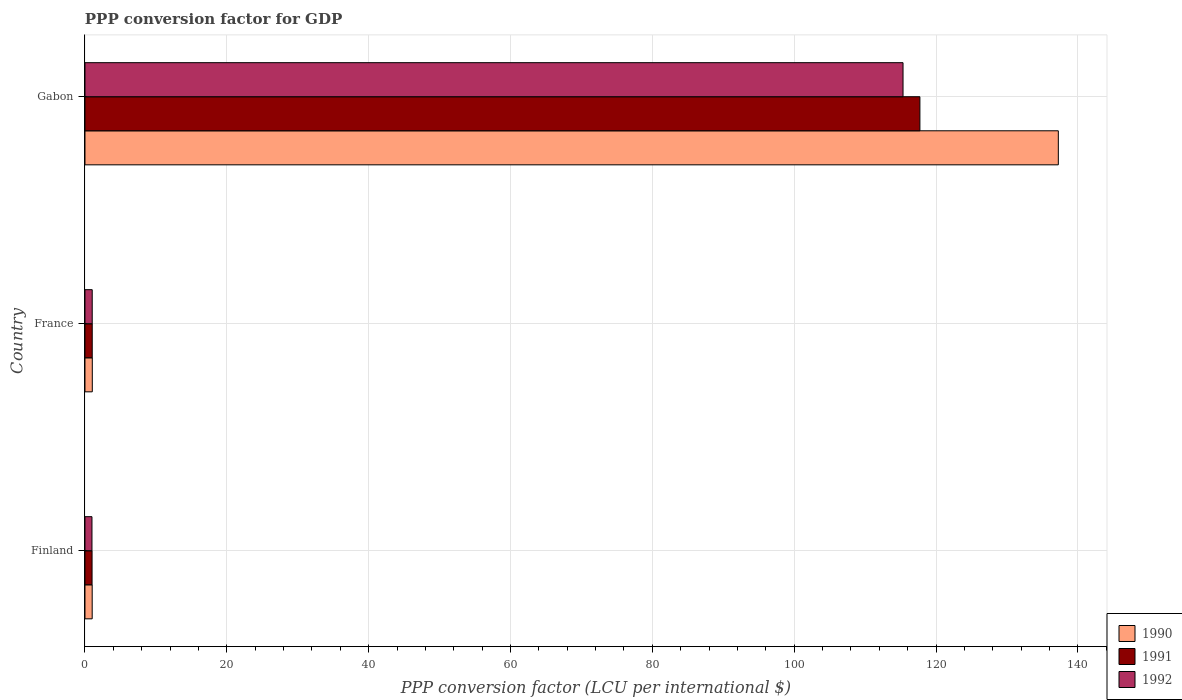What is the label of the 1st group of bars from the top?
Provide a short and direct response. Gabon. What is the PPP conversion factor for GDP in 1990 in Finland?
Provide a succinct answer. 1.02. Across all countries, what is the maximum PPP conversion factor for GDP in 1990?
Provide a short and direct response. 137.25. Across all countries, what is the minimum PPP conversion factor for GDP in 1991?
Your response must be concise. 1. In which country was the PPP conversion factor for GDP in 1992 maximum?
Give a very brief answer. Gabon. What is the total PPP conversion factor for GDP in 1991 in the graph?
Provide a short and direct response. 119.75. What is the difference between the PPP conversion factor for GDP in 1991 in France and that in Gabon?
Your response must be concise. -116.7. What is the difference between the PPP conversion factor for GDP in 1991 in Gabon and the PPP conversion factor for GDP in 1992 in Finland?
Keep it short and to the point. 116.74. What is the average PPP conversion factor for GDP in 1991 per country?
Ensure brevity in your answer.  39.92. What is the difference between the PPP conversion factor for GDP in 1992 and PPP conversion factor for GDP in 1990 in France?
Ensure brevity in your answer.  -0.01. What is the ratio of the PPP conversion factor for GDP in 1992 in Finland to that in France?
Offer a terse response. 0.97. What is the difference between the highest and the second highest PPP conversion factor for GDP in 1991?
Offer a very short reply. 116.7. What is the difference between the highest and the lowest PPP conversion factor for GDP in 1992?
Provide a short and direct response. 114.36. What does the 3rd bar from the bottom in Gabon represents?
Your answer should be compact. 1992. How many bars are there?
Your answer should be compact. 9. Are all the bars in the graph horizontal?
Offer a very short reply. Yes. How many countries are there in the graph?
Provide a succinct answer. 3. What is the difference between two consecutive major ticks on the X-axis?
Your answer should be compact. 20. What is the title of the graph?
Make the answer very short. PPP conversion factor for GDP. Does "1978" appear as one of the legend labels in the graph?
Your answer should be compact. No. What is the label or title of the X-axis?
Provide a succinct answer. PPP conversion factor (LCU per international $). What is the label or title of the Y-axis?
Offer a terse response. Country. What is the PPP conversion factor (LCU per international $) in 1990 in Finland?
Offer a terse response. 1.02. What is the PPP conversion factor (LCU per international $) in 1991 in Finland?
Your response must be concise. 1. What is the PPP conversion factor (LCU per international $) in 1992 in Finland?
Offer a very short reply. 0.99. What is the PPP conversion factor (LCU per international $) of 1990 in France?
Your answer should be compact. 1.03. What is the PPP conversion factor (LCU per international $) of 1991 in France?
Keep it short and to the point. 1.02. What is the PPP conversion factor (LCU per international $) in 1992 in France?
Offer a very short reply. 1.02. What is the PPP conversion factor (LCU per international $) of 1990 in Gabon?
Give a very brief answer. 137.25. What is the PPP conversion factor (LCU per international $) of 1991 in Gabon?
Make the answer very short. 117.73. What is the PPP conversion factor (LCU per international $) in 1992 in Gabon?
Your answer should be very brief. 115.35. Across all countries, what is the maximum PPP conversion factor (LCU per international $) in 1990?
Offer a terse response. 137.25. Across all countries, what is the maximum PPP conversion factor (LCU per international $) of 1991?
Offer a terse response. 117.73. Across all countries, what is the maximum PPP conversion factor (LCU per international $) of 1992?
Ensure brevity in your answer.  115.35. Across all countries, what is the minimum PPP conversion factor (LCU per international $) in 1990?
Your answer should be very brief. 1.02. Across all countries, what is the minimum PPP conversion factor (LCU per international $) of 1991?
Provide a short and direct response. 1. Across all countries, what is the minimum PPP conversion factor (LCU per international $) in 1992?
Your answer should be very brief. 0.99. What is the total PPP conversion factor (LCU per international $) of 1990 in the graph?
Provide a short and direct response. 139.3. What is the total PPP conversion factor (LCU per international $) in 1991 in the graph?
Your answer should be compact. 119.75. What is the total PPP conversion factor (LCU per international $) in 1992 in the graph?
Your answer should be compact. 117.36. What is the difference between the PPP conversion factor (LCU per international $) of 1990 in Finland and that in France?
Provide a succinct answer. -0.01. What is the difference between the PPP conversion factor (LCU per international $) of 1991 in Finland and that in France?
Provide a short and direct response. -0.02. What is the difference between the PPP conversion factor (LCU per international $) of 1992 in Finland and that in France?
Offer a very short reply. -0.03. What is the difference between the PPP conversion factor (LCU per international $) in 1990 in Finland and that in Gabon?
Offer a very short reply. -136.23. What is the difference between the PPP conversion factor (LCU per international $) in 1991 in Finland and that in Gabon?
Keep it short and to the point. -116.73. What is the difference between the PPP conversion factor (LCU per international $) in 1992 in Finland and that in Gabon?
Provide a succinct answer. -114.36. What is the difference between the PPP conversion factor (LCU per international $) of 1990 in France and that in Gabon?
Provide a short and direct response. -136.21. What is the difference between the PPP conversion factor (LCU per international $) of 1991 in France and that in Gabon?
Provide a succinct answer. -116.7. What is the difference between the PPP conversion factor (LCU per international $) of 1992 in France and that in Gabon?
Your answer should be very brief. -114.33. What is the difference between the PPP conversion factor (LCU per international $) of 1990 in Finland and the PPP conversion factor (LCU per international $) of 1991 in France?
Make the answer very short. -0.01. What is the difference between the PPP conversion factor (LCU per international $) of 1990 in Finland and the PPP conversion factor (LCU per international $) of 1992 in France?
Ensure brevity in your answer.  -0. What is the difference between the PPP conversion factor (LCU per international $) in 1991 in Finland and the PPP conversion factor (LCU per international $) in 1992 in France?
Offer a very short reply. -0.02. What is the difference between the PPP conversion factor (LCU per international $) in 1990 in Finland and the PPP conversion factor (LCU per international $) in 1991 in Gabon?
Make the answer very short. -116.71. What is the difference between the PPP conversion factor (LCU per international $) in 1990 in Finland and the PPP conversion factor (LCU per international $) in 1992 in Gabon?
Your answer should be compact. -114.33. What is the difference between the PPP conversion factor (LCU per international $) in 1991 in Finland and the PPP conversion factor (LCU per international $) in 1992 in Gabon?
Make the answer very short. -114.35. What is the difference between the PPP conversion factor (LCU per international $) of 1990 in France and the PPP conversion factor (LCU per international $) of 1991 in Gabon?
Offer a very short reply. -116.7. What is the difference between the PPP conversion factor (LCU per international $) in 1990 in France and the PPP conversion factor (LCU per international $) in 1992 in Gabon?
Give a very brief answer. -114.32. What is the difference between the PPP conversion factor (LCU per international $) in 1991 in France and the PPP conversion factor (LCU per international $) in 1992 in Gabon?
Give a very brief answer. -114.33. What is the average PPP conversion factor (LCU per international $) in 1990 per country?
Offer a terse response. 46.43. What is the average PPP conversion factor (LCU per international $) in 1991 per country?
Offer a terse response. 39.92. What is the average PPP conversion factor (LCU per international $) in 1992 per country?
Your answer should be compact. 39.12. What is the difference between the PPP conversion factor (LCU per international $) in 1990 and PPP conversion factor (LCU per international $) in 1991 in Finland?
Make the answer very short. 0.02. What is the difference between the PPP conversion factor (LCU per international $) of 1990 and PPP conversion factor (LCU per international $) of 1992 in Finland?
Your answer should be very brief. 0.03. What is the difference between the PPP conversion factor (LCU per international $) of 1991 and PPP conversion factor (LCU per international $) of 1992 in Finland?
Your answer should be very brief. 0.01. What is the difference between the PPP conversion factor (LCU per international $) in 1990 and PPP conversion factor (LCU per international $) in 1991 in France?
Your answer should be very brief. 0.01. What is the difference between the PPP conversion factor (LCU per international $) in 1990 and PPP conversion factor (LCU per international $) in 1992 in France?
Offer a very short reply. 0.01. What is the difference between the PPP conversion factor (LCU per international $) in 1991 and PPP conversion factor (LCU per international $) in 1992 in France?
Your answer should be compact. 0. What is the difference between the PPP conversion factor (LCU per international $) in 1990 and PPP conversion factor (LCU per international $) in 1991 in Gabon?
Keep it short and to the point. 19.52. What is the difference between the PPP conversion factor (LCU per international $) in 1990 and PPP conversion factor (LCU per international $) in 1992 in Gabon?
Provide a short and direct response. 21.9. What is the difference between the PPP conversion factor (LCU per international $) in 1991 and PPP conversion factor (LCU per international $) in 1992 in Gabon?
Your answer should be compact. 2.38. What is the ratio of the PPP conversion factor (LCU per international $) of 1990 in Finland to that in France?
Provide a short and direct response. 0.99. What is the ratio of the PPP conversion factor (LCU per international $) in 1991 in Finland to that in France?
Provide a short and direct response. 0.98. What is the ratio of the PPP conversion factor (LCU per international $) of 1992 in Finland to that in France?
Provide a succinct answer. 0.97. What is the ratio of the PPP conversion factor (LCU per international $) in 1990 in Finland to that in Gabon?
Provide a succinct answer. 0.01. What is the ratio of the PPP conversion factor (LCU per international $) of 1991 in Finland to that in Gabon?
Provide a succinct answer. 0.01. What is the ratio of the PPP conversion factor (LCU per international $) of 1992 in Finland to that in Gabon?
Keep it short and to the point. 0.01. What is the ratio of the PPP conversion factor (LCU per international $) of 1990 in France to that in Gabon?
Provide a succinct answer. 0.01. What is the ratio of the PPP conversion factor (LCU per international $) of 1991 in France to that in Gabon?
Your answer should be very brief. 0.01. What is the ratio of the PPP conversion factor (LCU per international $) in 1992 in France to that in Gabon?
Your answer should be compact. 0.01. What is the difference between the highest and the second highest PPP conversion factor (LCU per international $) of 1990?
Offer a terse response. 136.21. What is the difference between the highest and the second highest PPP conversion factor (LCU per international $) of 1991?
Provide a short and direct response. 116.7. What is the difference between the highest and the second highest PPP conversion factor (LCU per international $) of 1992?
Ensure brevity in your answer.  114.33. What is the difference between the highest and the lowest PPP conversion factor (LCU per international $) of 1990?
Provide a succinct answer. 136.23. What is the difference between the highest and the lowest PPP conversion factor (LCU per international $) of 1991?
Offer a terse response. 116.73. What is the difference between the highest and the lowest PPP conversion factor (LCU per international $) of 1992?
Provide a succinct answer. 114.36. 